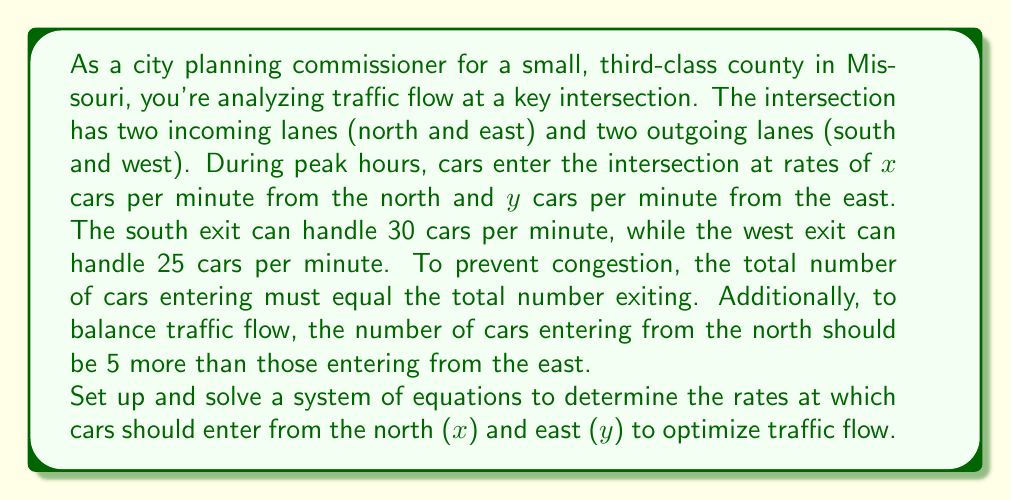Could you help me with this problem? Let's approach this step-by-step:

1) First, let's set up our equations based on the given information:

   Equation 1 (Total cars entering = Total cars exiting):
   $$x + y = 30 + 25$$

   Equation 2 (North entry is 5 more than East entry):
   $$x = y + 5$$

2) Simplify Equation 1:
   $$x + y = 55$$

3) Now we have a system of two equations with two unknowns:
   $$\begin{cases}
   x + y = 55 \\
   x = y + 5
   \end{cases}$$

4) We can solve this by substitution. Let's substitute the second equation into the first:
   $$(y + 5) + y = 55$$

5) Simplify:
   $$2y + 5 = 55$$

6) Subtract 5 from both sides:
   $$2y = 50$$

7) Divide both sides by 2:
   $$y = 25$$

8) Now that we know $y$, we can find $x$ using either of our original equations. Let's use the second one:
   $$x = y + 5 = 25 + 5 = 30$$

9) Let's verify our solution satisfies both original equations:
   Equation 1: $30 + 25 = 55$ (✓)
   Equation 2: $30 = 25 + 5$ (✓)

Therefore, to optimize traffic flow, cars should enter at a rate of 30 per minute from the north and 25 per minute from the east.
Answer: $x = 30$ cars per minute from the north, $y = 25$ cars per minute from the east 